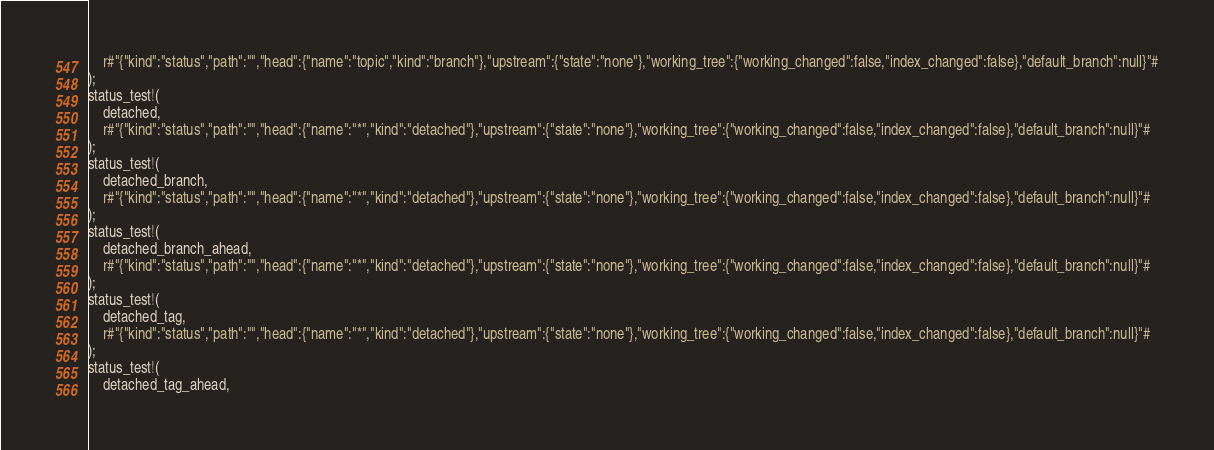<code> <loc_0><loc_0><loc_500><loc_500><_Rust_>    r#"{"kind":"status","path":"","head":{"name":"topic","kind":"branch"},"upstream":{"state":"none"},"working_tree":{"working_changed":false,"index_changed":false},"default_branch":null}"#
);
status_test!(
    detached,
    r#"{"kind":"status","path":"","head":{"name":"*","kind":"detached"},"upstream":{"state":"none"},"working_tree":{"working_changed":false,"index_changed":false},"default_branch":null}"#
);
status_test!(
    detached_branch,
    r#"{"kind":"status","path":"","head":{"name":"*","kind":"detached"},"upstream":{"state":"none"},"working_tree":{"working_changed":false,"index_changed":false},"default_branch":null}"#
);
status_test!(
    detached_branch_ahead,
    r#"{"kind":"status","path":"","head":{"name":"*","kind":"detached"},"upstream":{"state":"none"},"working_tree":{"working_changed":false,"index_changed":false},"default_branch":null}"#
);
status_test!(
    detached_tag,
    r#"{"kind":"status","path":"","head":{"name":"*","kind":"detached"},"upstream":{"state":"none"},"working_tree":{"working_changed":false,"index_changed":false},"default_branch":null}"#
);
status_test!(
    detached_tag_ahead,</code> 